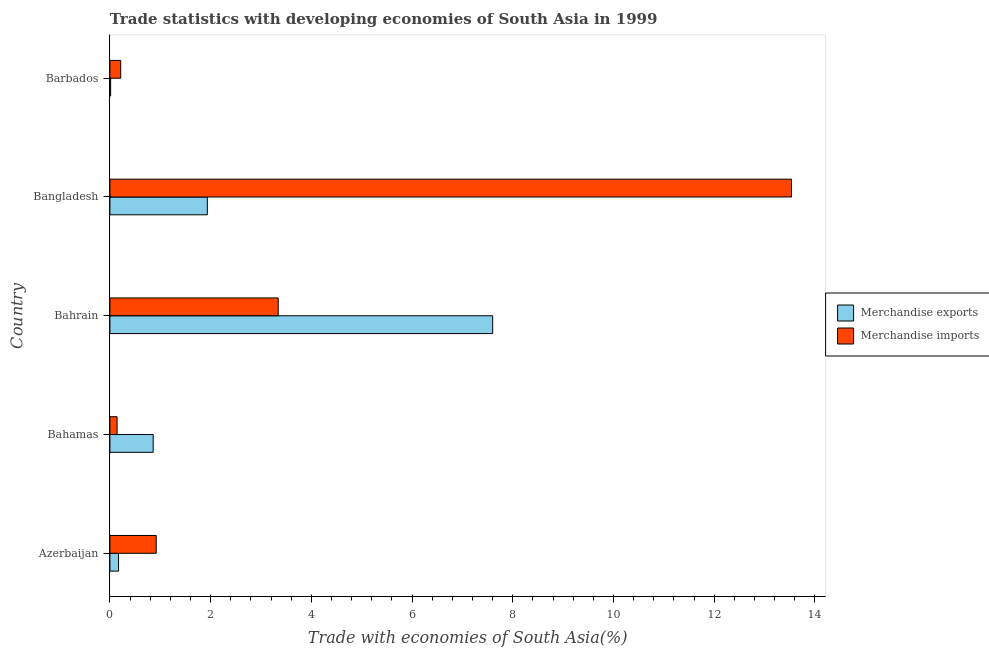How many groups of bars are there?
Your answer should be very brief. 5. Are the number of bars on each tick of the Y-axis equal?
Offer a terse response. Yes. How many bars are there on the 3rd tick from the top?
Give a very brief answer. 2. What is the label of the 4th group of bars from the top?
Your answer should be very brief. Bahamas. In how many cases, is the number of bars for a given country not equal to the number of legend labels?
Your answer should be compact. 0. What is the merchandise exports in Barbados?
Ensure brevity in your answer.  0.01. Across all countries, what is the maximum merchandise imports?
Keep it short and to the point. 13.53. Across all countries, what is the minimum merchandise exports?
Provide a succinct answer. 0.01. In which country was the merchandise exports maximum?
Offer a terse response. Bahrain. In which country was the merchandise imports minimum?
Give a very brief answer. Bahamas. What is the total merchandise imports in the graph?
Provide a short and direct response. 18.15. What is the difference between the merchandise exports in Bangladesh and that in Barbados?
Your answer should be very brief. 1.92. What is the difference between the merchandise imports in Bahrain and the merchandise exports in Azerbaijan?
Make the answer very short. 3.17. What is the average merchandise exports per country?
Make the answer very short. 2.12. In how many countries, is the merchandise imports greater than 9.6 %?
Give a very brief answer. 1. What is the ratio of the merchandise exports in Bahamas to that in Bahrain?
Your response must be concise. 0.11. Is the difference between the merchandise exports in Azerbaijan and Barbados greater than the difference between the merchandise imports in Azerbaijan and Barbados?
Offer a terse response. No. What is the difference between the highest and the second highest merchandise exports?
Give a very brief answer. 5.67. What is the difference between the highest and the lowest merchandise exports?
Provide a succinct answer. 7.59. Is the sum of the merchandise imports in Azerbaijan and Barbados greater than the maximum merchandise exports across all countries?
Make the answer very short. No. What does the 1st bar from the bottom in Azerbaijan represents?
Your answer should be compact. Merchandise exports. How many bars are there?
Offer a terse response. 10. Are all the bars in the graph horizontal?
Keep it short and to the point. Yes. Does the graph contain any zero values?
Ensure brevity in your answer.  No. What is the title of the graph?
Keep it short and to the point. Trade statistics with developing economies of South Asia in 1999. What is the label or title of the X-axis?
Your answer should be compact. Trade with economies of South Asia(%). What is the label or title of the Y-axis?
Keep it short and to the point. Country. What is the Trade with economies of South Asia(%) in Merchandise exports in Azerbaijan?
Make the answer very short. 0.17. What is the Trade with economies of South Asia(%) of Merchandise imports in Azerbaijan?
Your answer should be very brief. 0.92. What is the Trade with economies of South Asia(%) in Merchandise exports in Bahamas?
Your response must be concise. 0.86. What is the Trade with economies of South Asia(%) in Merchandise imports in Bahamas?
Your response must be concise. 0.14. What is the Trade with economies of South Asia(%) of Merchandise exports in Bahrain?
Give a very brief answer. 7.6. What is the Trade with economies of South Asia(%) in Merchandise imports in Bahrain?
Keep it short and to the point. 3.34. What is the Trade with economies of South Asia(%) of Merchandise exports in Bangladesh?
Ensure brevity in your answer.  1.93. What is the Trade with economies of South Asia(%) in Merchandise imports in Bangladesh?
Your answer should be compact. 13.53. What is the Trade with economies of South Asia(%) of Merchandise exports in Barbados?
Ensure brevity in your answer.  0.01. What is the Trade with economies of South Asia(%) of Merchandise imports in Barbados?
Ensure brevity in your answer.  0.21. Across all countries, what is the maximum Trade with economies of South Asia(%) of Merchandise exports?
Your answer should be compact. 7.6. Across all countries, what is the maximum Trade with economies of South Asia(%) of Merchandise imports?
Keep it short and to the point. 13.53. Across all countries, what is the minimum Trade with economies of South Asia(%) of Merchandise exports?
Your answer should be very brief. 0.01. Across all countries, what is the minimum Trade with economies of South Asia(%) in Merchandise imports?
Keep it short and to the point. 0.14. What is the total Trade with economies of South Asia(%) in Merchandise exports in the graph?
Your response must be concise. 10.58. What is the total Trade with economies of South Asia(%) of Merchandise imports in the graph?
Your answer should be compact. 18.15. What is the difference between the Trade with economies of South Asia(%) of Merchandise exports in Azerbaijan and that in Bahamas?
Make the answer very short. -0.69. What is the difference between the Trade with economies of South Asia(%) in Merchandise imports in Azerbaijan and that in Bahamas?
Your answer should be very brief. 0.78. What is the difference between the Trade with economies of South Asia(%) in Merchandise exports in Azerbaijan and that in Bahrain?
Provide a short and direct response. -7.43. What is the difference between the Trade with economies of South Asia(%) of Merchandise imports in Azerbaijan and that in Bahrain?
Offer a very short reply. -2.42. What is the difference between the Trade with economies of South Asia(%) in Merchandise exports in Azerbaijan and that in Bangladesh?
Provide a short and direct response. -1.76. What is the difference between the Trade with economies of South Asia(%) of Merchandise imports in Azerbaijan and that in Bangladesh?
Your answer should be very brief. -12.61. What is the difference between the Trade with economies of South Asia(%) in Merchandise exports in Azerbaijan and that in Barbados?
Give a very brief answer. 0.16. What is the difference between the Trade with economies of South Asia(%) of Merchandise imports in Azerbaijan and that in Barbados?
Give a very brief answer. 0.71. What is the difference between the Trade with economies of South Asia(%) in Merchandise exports in Bahamas and that in Bahrain?
Your answer should be compact. -6.74. What is the difference between the Trade with economies of South Asia(%) of Merchandise imports in Bahamas and that in Bahrain?
Provide a succinct answer. -3.2. What is the difference between the Trade with economies of South Asia(%) in Merchandise exports in Bahamas and that in Bangladesh?
Your answer should be compact. -1.08. What is the difference between the Trade with economies of South Asia(%) of Merchandise imports in Bahamas and that in Bangladesh?
Make the answer very short. -13.39. What is the difference between the Trade with economies of South Asia(%) in Merchandise exports in Bahamas and that in Barbados?
Make the answer very short. 0.84. What is the difference between the Trade with economies of South Asia(%) of Merchandise imports in Bahamas and that in Barbados?
Provide a succinct answer. -0.07. What is the difference between the Trade with economies of South Asia(%) in Merchandise exports in Bahrain and that in Bangladesh?
Your answer should be compact. 5.67. What is the difference between the Trade with economies of South Asia(%) in Merchandise imports in Bahrain and that in Bangladesh?
Keep it short and to the point. -10.19. What is the difference between the Trade with economies of South Asia(%) in Merchandise exports in Bahrain and that in Barbados?
Provide a short and direct response. 7.59. What is the difference between the Trade with economies of South Asia(%) in Merchandise imports in Bahrain and that in Barbados?
Your answer should be compact. 3.13. What is the difference between the Trade with economies of South Asia(%) in Merchandise exports in Bangladesh and that in Barbados?
Offer a very short reply. 1.92. What is the difference between the Trade with economies of South Asia(%) of Merchandise imports in Bangladesh and that in Barbados?
Your answer should be compact. 13.32. What is the difference between the Trade with economies of South Asia(%) of Merchandise exports in Azerbaijan and the Trade with economies of South Asia(%) of Merchandise imports in Bahamas?
Offer a terse response. 0.03. What is the difference between the Trade with economies of South Asia(%) in Merchandise exports in Azerbaijan and the Trade with economies of South Asia(%) in Merchandise imports in Bahrain?
Ensure brevity in your answer.  -3.17. What is the difference between the Trade with economies of South Asia(%) of Merchandise exports in Azerbaijan and the Trade with economies of South Asia(%) of Merchandise imports in Bangladesh?
Keep it short and to the point. -13.36. What is the difference between the Trade with economies of South Asia(%) in Merchandise exports in Azerbaijan and the Trade with economies of South Asia(%) in Merchandise imports in Barbados?
Provide a succinct answer. -0.04. What is the difference between the Trade with economies of South Asia(%) of Merchandise exports in Bahamas and the Trade with economies of South Asia(%) of Merchandise imports in Bahrain?
Provide a short and direct response. -2.48. What is the difference between the Trade with economies of South Asia(%) of Merchandise exports in Bahamas and the Trade with economies of South Asia(%) of Merchandise imports in Bangladesh?
Provide a succinct answer. -12.67. What is the difference between the Trade with economies of South Asia(%) in Merchandise exports in Bahamas and the Trade with economies of South Asia(%) in Merchandise imports in Barbados?
Your response must be concise. 0.64. What is the difference between the Trade with economies of South Asia(%) of Merchandise exports in Bahrain and the Trade with economies of South Asia(%) of Merchandise imports in Bangladesh?
Ensure brevity in your answer.  -5.93. What is the difference between the Trade with economies of South Asia(%) in Merchandise exports in Bahrain and the Trade with economies of South Asia(%) in Merchandise imports in Barbados?
Give a very brief answer. 7.39. What is the difference between the Trade with economies of South Asia(%) of Merchandise exports in Bangladesh and the Trade with economies of South Asia(%) of Merchandise imports in Barbados?
Make the answer very short. 1.72. What is the average Trade with economies of South Asia(%) in Merchandise exports per country?
Your answer should be very brief. 2.12. What is the average Trade with economies of South Asia(%) in Merchandise imports per country?
Provide a succinct answer. 3.63. What is the difference between the Trade with economies of South Asia(%) of Merchandise exports and Trade with economies of South Asia(%) of Merchandise imports in Azerbaijan?
Ensure brevity in your answer.  -0.75. What is the difference between the Trade with economies of South Asia(%) of Merchandise exports and Trade with economies of South Asia(%) of Merchandise imports in Bahamas?
Give a very brief answer. 0.72. What is the difference between the Trade with economies of South Asia(%) in Merchandise exports and Trade with economies of South Asia(%) in Merchandise imports in Bahrain?
Your answer should be very brief. 4.26. What is the difference between the Trade with economies of South Asia(%) in Merchandise exports and Trade with economies of South Asia(%) in Merchandise imports in Bangladesh?
Your response must be concise. -11.6. What is the difference between the Trade with economies of South Asia(%) in Merchandise exports and Trade with economies of South Asia(%) in Merchandise imports in Barbados?
Your answer should be compact. -0.2. What is the ratio of the Trade with economies of South Asia(%) in Merchandise exports in Azerbaijan to that in Bahamas?
Offer a terse response. 0.2. What is the ratio of the Trade with economies of South Asia(%) in Merchandise imports in Azerbaijan to that in Bahamas?
Make the answer very short. 6.45. What is the ratio of the Trade with economies of South Asia(%) in Merchandise exports in Azerbaijan to that in Bahrain?
Keep it short and to the point. 0.02. What is the ratio of the Trade with economies of South Asia(%) of Merchandise imports in Azerbaijan to that in Bahrain?
Give a very brief answer. 0.28. What is the ratio of the Trade with economies of South Asia(%) in Merchandise exports in Azerbaijan to that in Bangladesh?
Keep it short and to the point. 0.09. What is the ratio of the Trade with economies of South Asia(%) of Merchandise imports in Azerbaijan to that in Bangladesh?
Make the answer very short. 0.07. What is the ratio of the Trade with economies of South Asia(%) in Merchandise exports in Azerbaijan to that in Barbados?
Offer a terse response. 11.81. What is the ratio of the Trade with economies of South Asia(%) in Merchandise imports in Azerbaijan to that in Barbados?
Ensure brevity in your answer.  4.28. What is the ratio of the Trade with economies of South Asia(%) of Merchandise exports in Bahamas to that in Bahrain?
Offer a terse response. 0.11. What is the ratio of the Trade with economies of South Asia(%) of Merchandise imports in Bahamas to that in Bahrain?
Provide a short and direct response. 0.04. What is the ratio of the Trade with economies of South Asia(%) in Merchandise exports in Bahamas to that in Bangladesh?
Give a very brief answer. 0.44. What is the ratio of the Trade with economies of South Asia(%) of Merchandise imports in Bahamas to that in Bangladesh?
Your answer should be very brief. 0.01. What is the ratio of the Trade with economies of South Asia(%) of Merchandise exports in Bahamas to that in Barbados?
Keep it short and to the point. 58.99. What is the ratio of the Trade with economies of South Asia(%) of Merchandise imports in Bahamas to that in Barbados?
Ensure brevity in your answer.  0.66. What is the ratio of the Trade with economies of South Asia(%) in Merchandise exports in Bahrain to that in Bangladesh?
Provide a short and direct response. 3.93. What is the ratio of the Trade with economies of South Asia(%) of Merchandise imports in Bahrain to that in Bangladesh?
Ensure brevity in your answer.  0.25. What is the ratio of the Trade with economies of South Asia(%) of Merchandise exports in Bahrain to that in Barbados?
Your answer should be compact. 521.77. What is the ratio of the Trade with economies of South Asia(%) in Merchandise imports in Bahrain to that in Barbados?
Offer a terse response. 15.56. What is the ratio of the Trade with economies of South Asia(%) in Merchandise exports in Bangladesh to that in Barbados?
Give a very brief answer. 132.81. What is the ratio of the Trade with economies of South Asia(%) of Merchandise imports in Bangladesh to that in Barbados?
Offer a very short reply. 63.01. What is the difference between the highest and the second highest Trade with economies of South Asia(%) in Merchandise exports?
Give a very brief answer. 5.67. What is the difference between the highest and the second highest Trade with economies of South Asia(%) of Merchandise imports?
Provide a succinct answer. 10.19. What is the difference between the highest and the lowest Trade with economies of South Asia(%) in Merchandise exports?
Offer a terse response. 7.59. What is the difference between the highest and the lowest Trade with economies of South Asia(%) of Merchandise imports?
Your response must be concise. 13.39. 